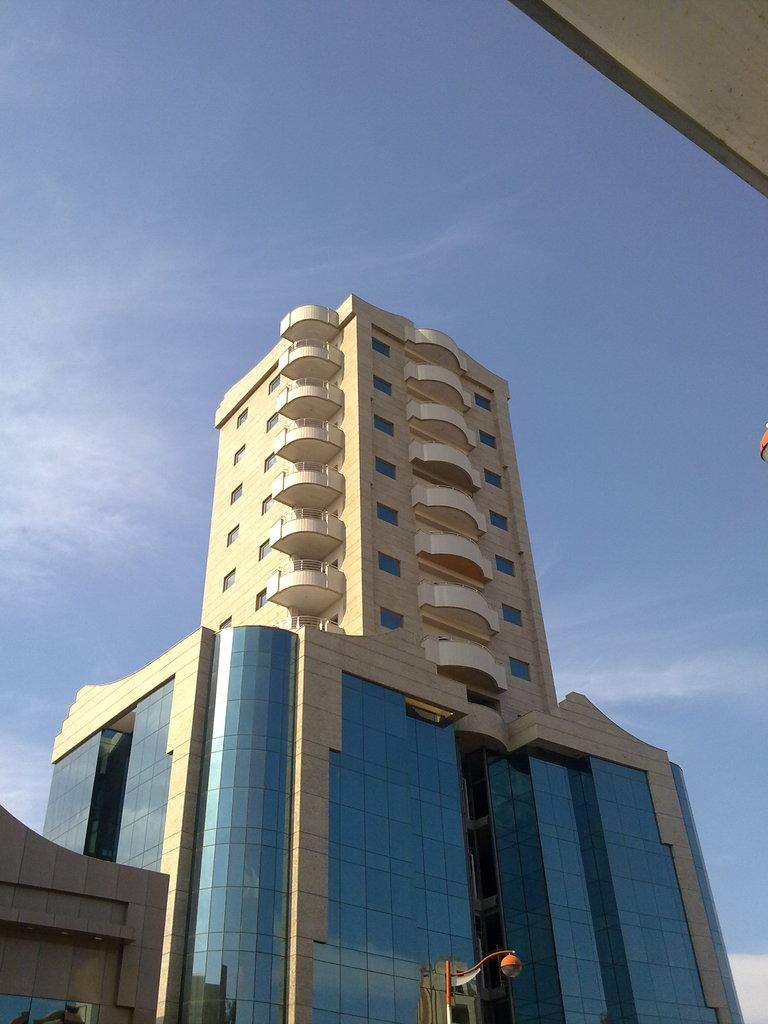What type of structures are present in the image? There are buildings in the image. What feature do the buildings have? The buildings have windows. What is attached to a pole in the image? There is a light attached to a pole in the image. What is visible at the top of the image? The sky is visible at the top of the image. Can you tell me how tall your dad is in the image? There is no person, specifically no dad, present in the image. 